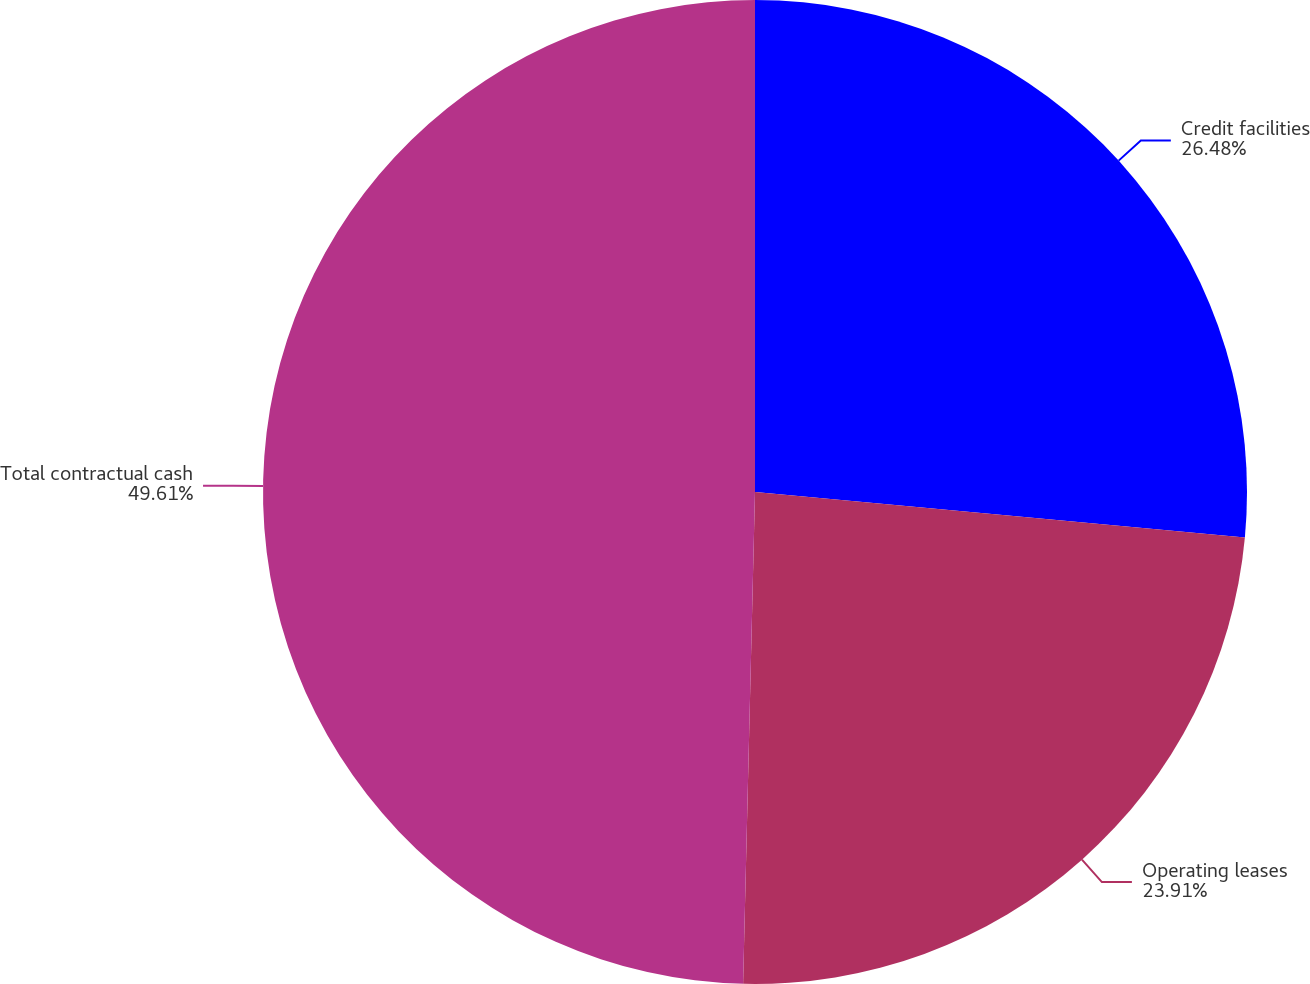Convert chart. <chart><loc_0><loc_0><loc_500><loc_500><pie_chart><fcel>Credit facilities<fcel>Operating leases<fcel>Total contractual cash<nl><fcel>26.48%<fcel>23.91%<fcel>49.62%<nl></chart> 